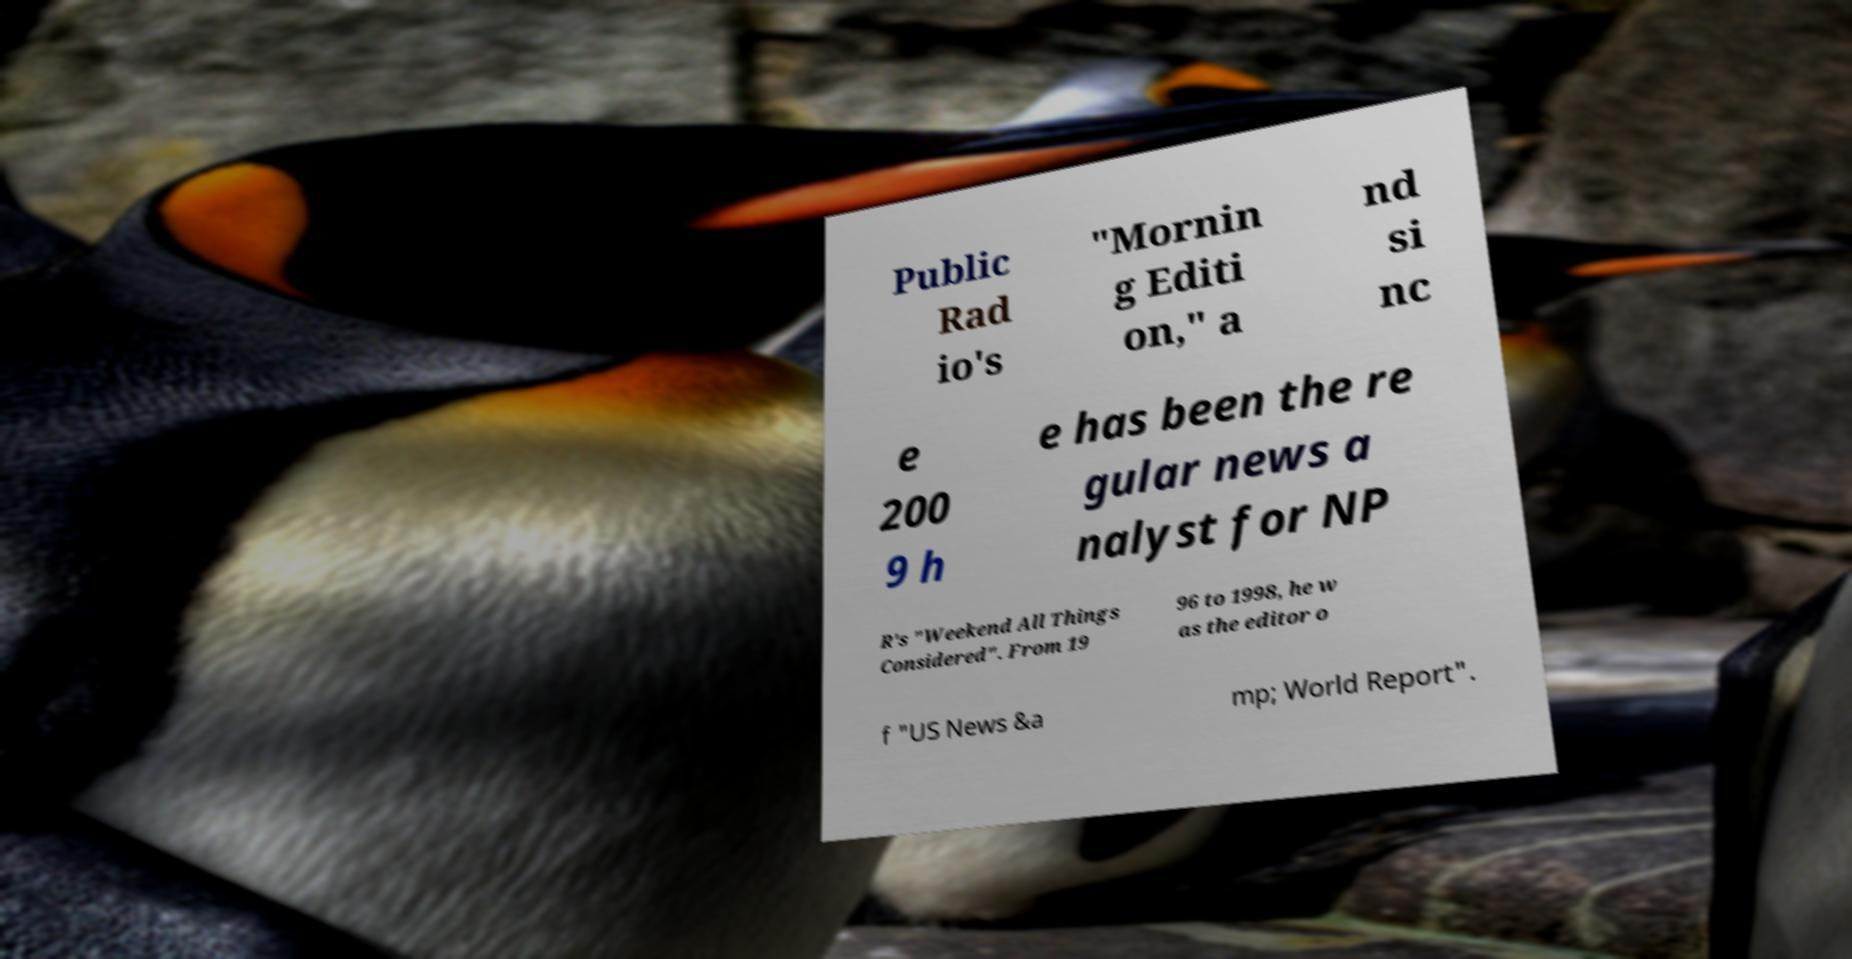Could you assist in decoding the text presented in this image and type it out clearly? Public Rad io's "Mornin g Editi on," a nd si nc e 200 9 h e has been the re gular news a nalyst for NP R's "Weekend All Things Considered". From 19 96 to 1998, he w as the editor o f "US News &a mp; World Report". 